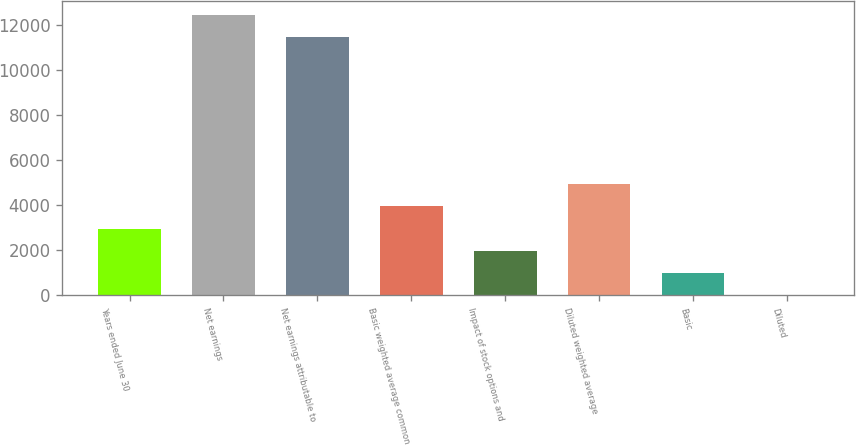<chart> <loc_0><loc_0><loc_500><loc_500><bar_chart><fcel>Years ended June 30<fcel>Net earnings<fcel>Net earnings attributable to<fcel>Basic weighted average common<fcel>Impact of stock options and<fcel>Diluted weighted average<fcel>Basic<fcel>Diluted<nl><fcel>2960.86<fcel>12442.2<fcel>11456.5<fcel>3946.59<fcel>1975.13<fcel>4932.32<fcel>989.4<fcel>3.67<nl></chart> 